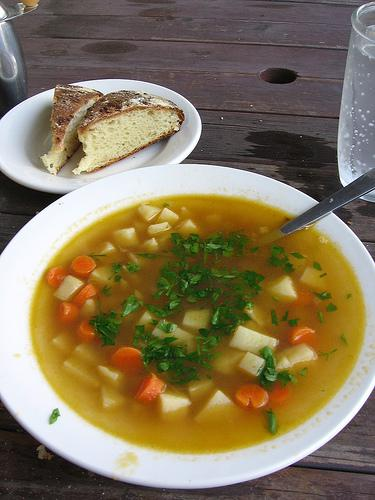Question: what is pictured?
Choices:
A. Food.
B. Dishes.
C. Silverware.
D. Cups.
Answer with the letter. Answer: A Question: when is this picture taken?
Choices:
A. During lunch.
B. During breakfast.
C. During dinner.
D. During dessert.
Answer with the letter. Answer: A Question: why is the table wet?
Choices:
A. Water from a potted plant.
B. Spilled milk.
C. Spilled juice.
D. Water from cup.
Answer with the letter. Answer: D Question: what color is the plate?
Choices:
A. White.
B. Blue.
C. Red.
D. Black.
Answer with the letter. Answer: A 